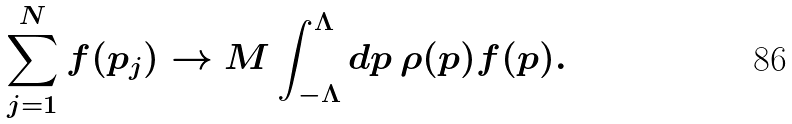Convert formula to latex. <formula><loc_0><loc_0><loc_500><loc_500>\sum _ { j = 1 } ^ { N } f ( p _ { j } ) \to M \int _ { - \Lambda } ^ { \Lambda } d p \, \rho ( p ) f ( p ) .</formula> 